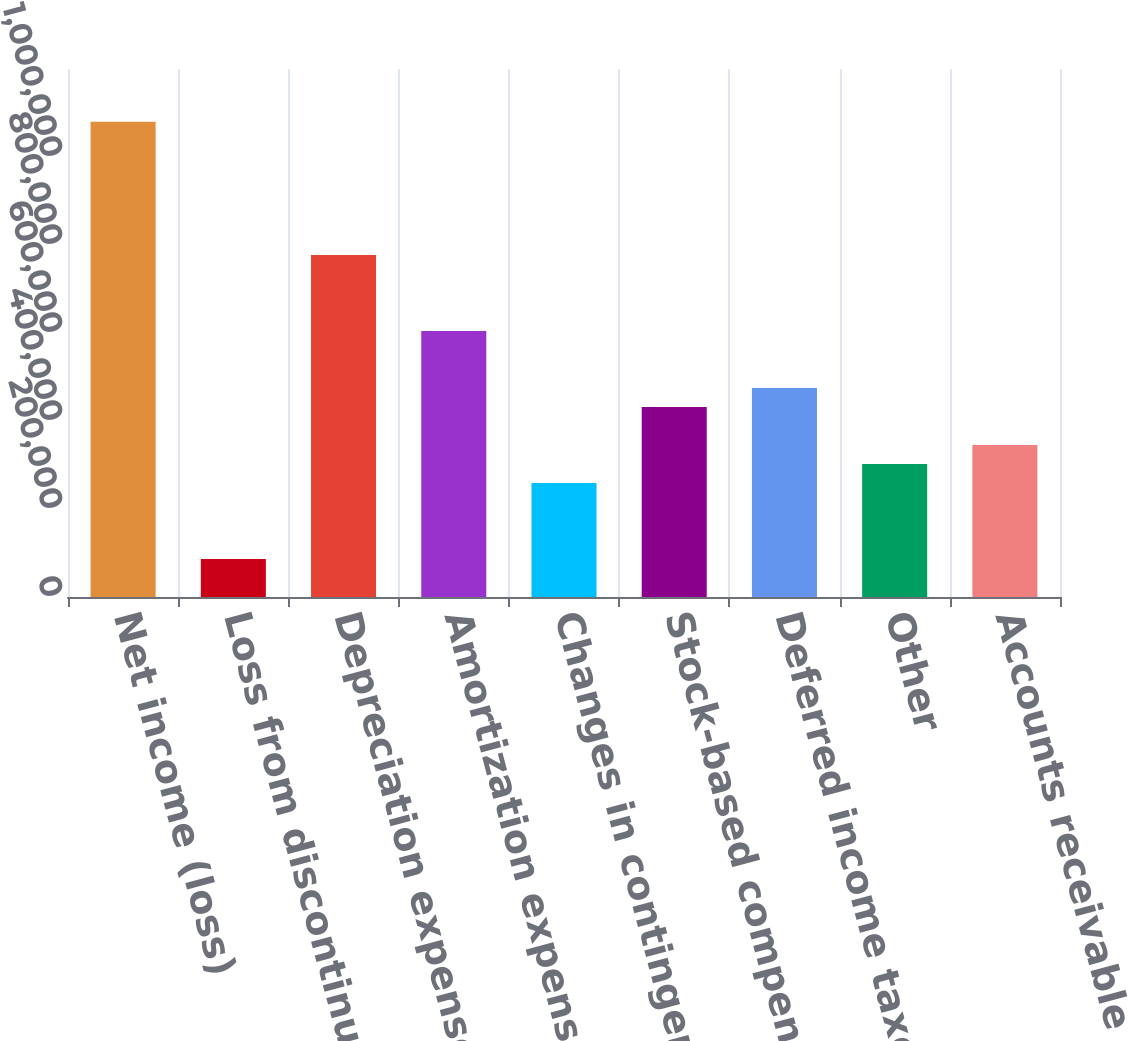Convert chart. <chart><loc_0><loc_0><loc_500><loc_500><bar_chart><fcel>Net income (loss)<fcel>Loss from discontinued<fcel>Depreciation expense<fcel>Amortization expense of<fcel>Changes in contingent<fcel>Stock-based compensation<fcel>Deferred income taxes net<fcel>Other<fcel>Accounts receivable<nl><fcel>1.0799e+06<fcel>86428.8<fcel>777539<fcel>604762<fcel>259206<fcel>431984<fcel>475178<fcel>302401<fcel>345595<nl></chart> 